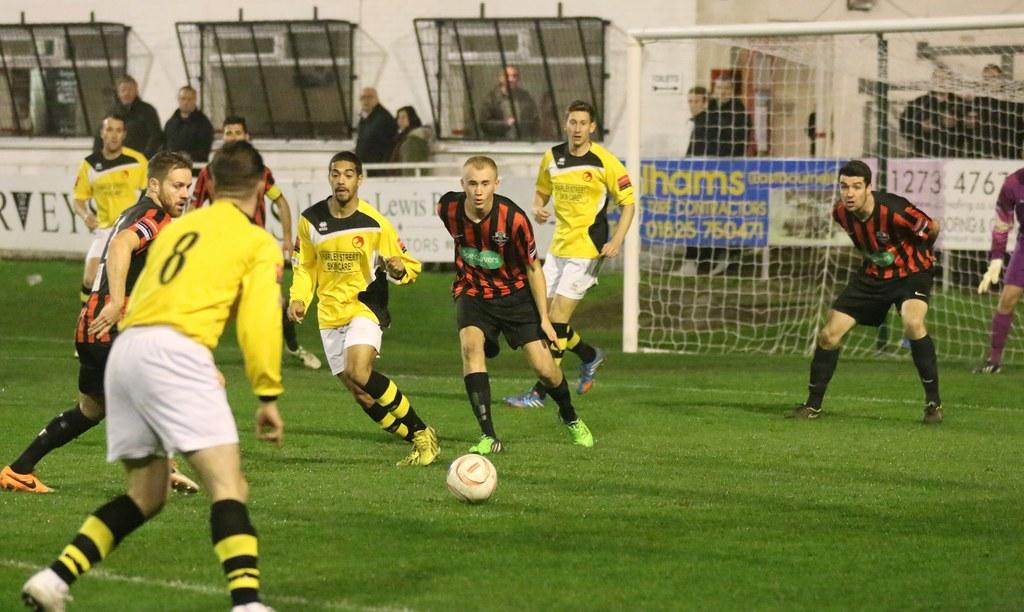Provide a one-sentence caption for the provided image. Player number 8 gets ready to get the ball from his opponents. 